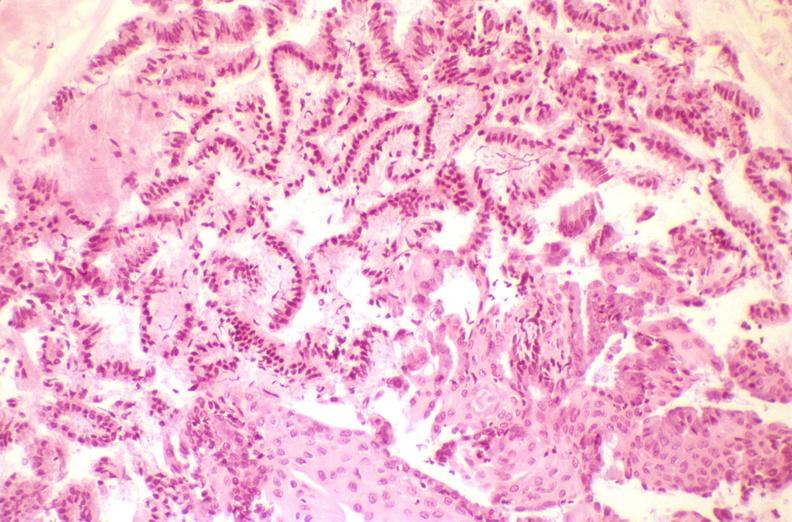does lymphangiomatosis show cervix, squamous metaplasia?
Answer the question using a single word or phrase. No 